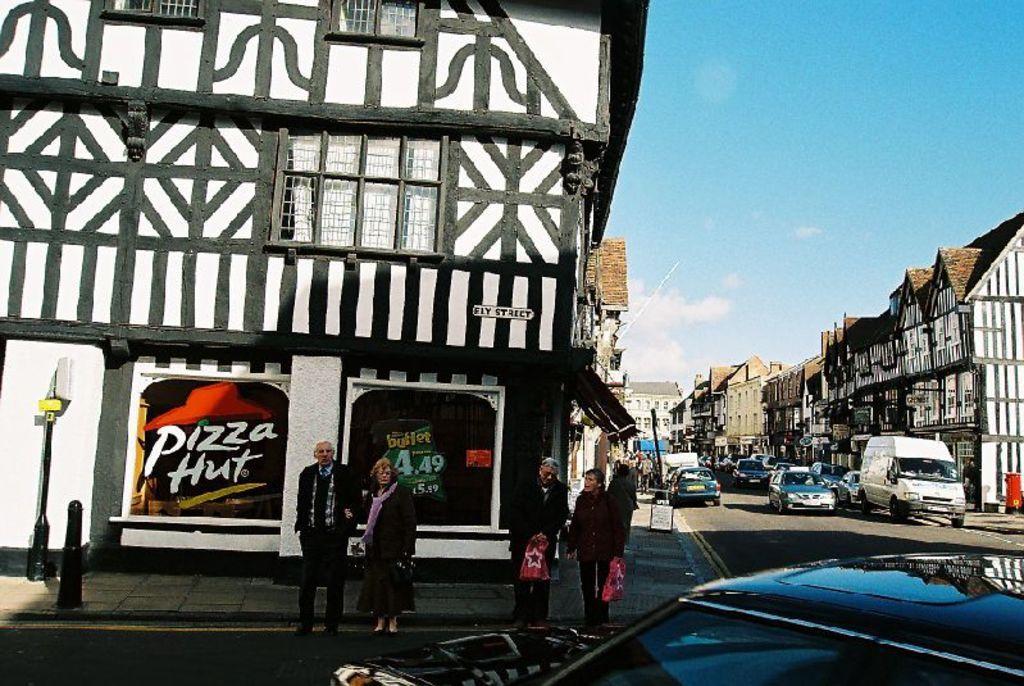Can you describe this image briefly? In this image I can see some vehicles on the road. I can see some people. On the left and right side, I can see the buildings. In the background, I can see the clouds in the sky. 